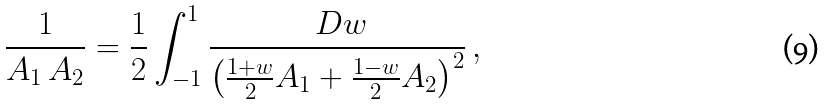<formula> <loc_0><loc_0><loc_500><loc_500>\frac { 1 } { A _ { 1 } \, A _ { 2 } } = \frac { 1 } { 2 } \int _ { - 1 } ^ { 1 } \frac { \ D w } { \left ( \frac { 1 + w } { 2 } A _ { 1 } + \frac { 1 - w } { 2 } A _ { 2 } \right ) ^ { 2 } } \, ,</formula> 